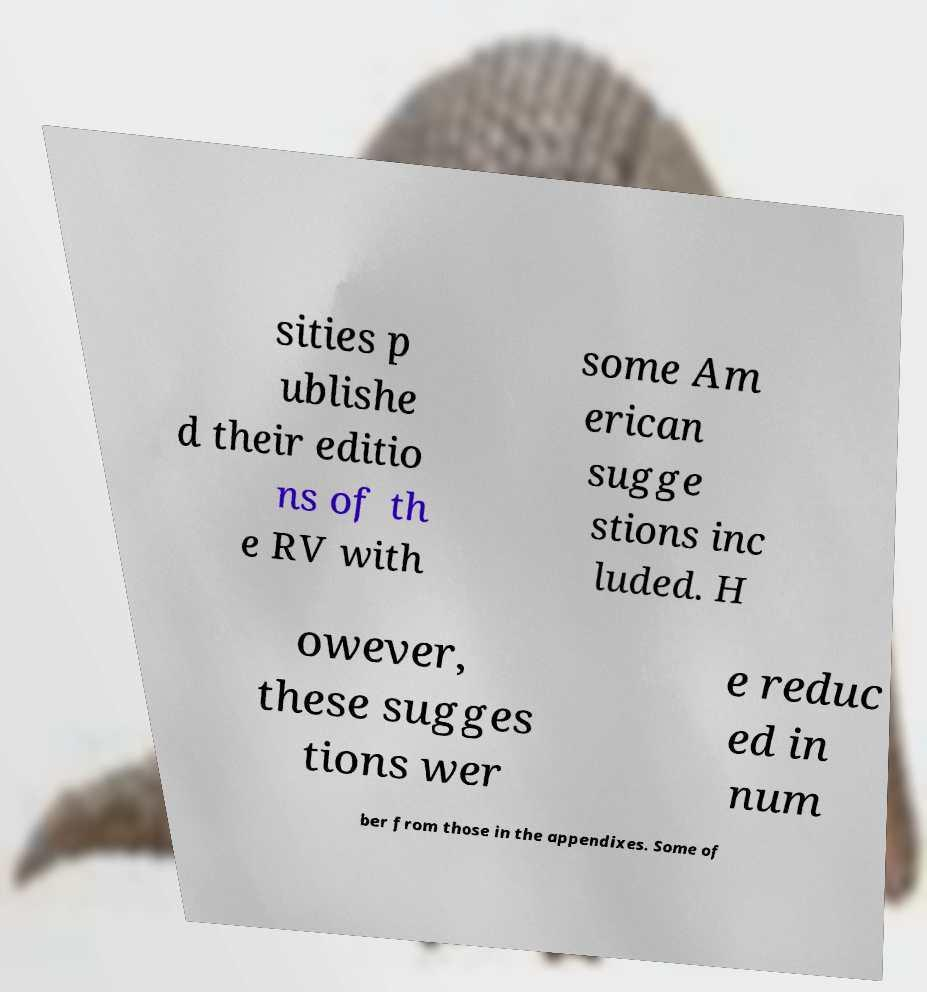Can you read and provide the text displayed in the image?This photo seems to have some interesting text. Can you extract and type it out for me? sities p ublishe d their editio ns of th e RV with some Am erican sugge stions inc luded. H owever, these sugges tions wer e reduc ed in num ber from those in the appendixes. Some of 